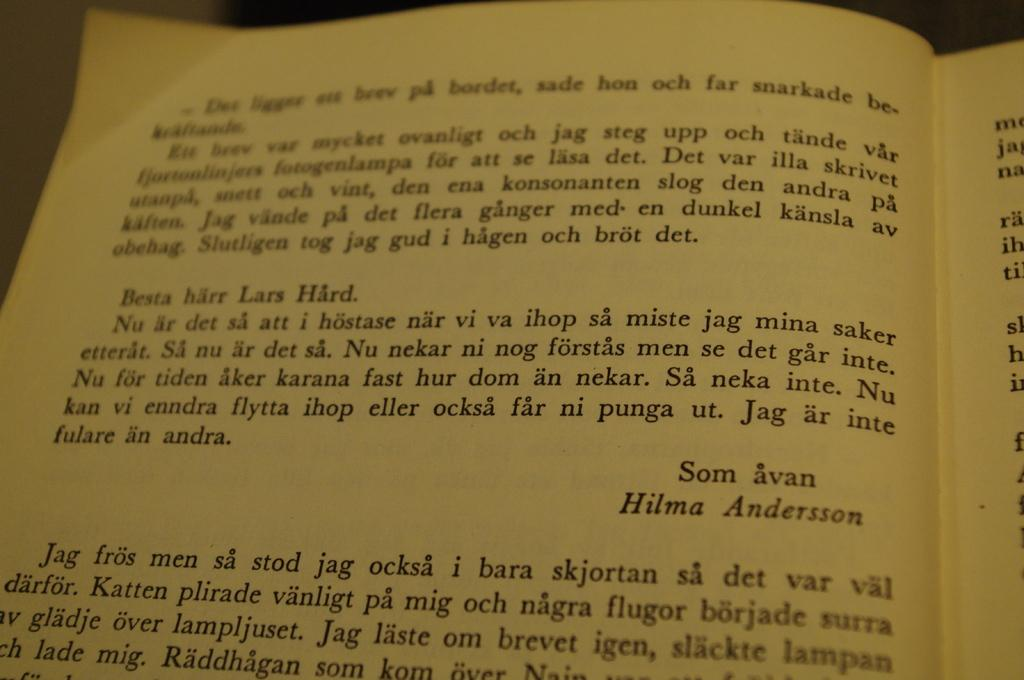<image>
Present a compact description of the photo's key features. Book open on a page that has the name Hilma Andersson near the middle. 